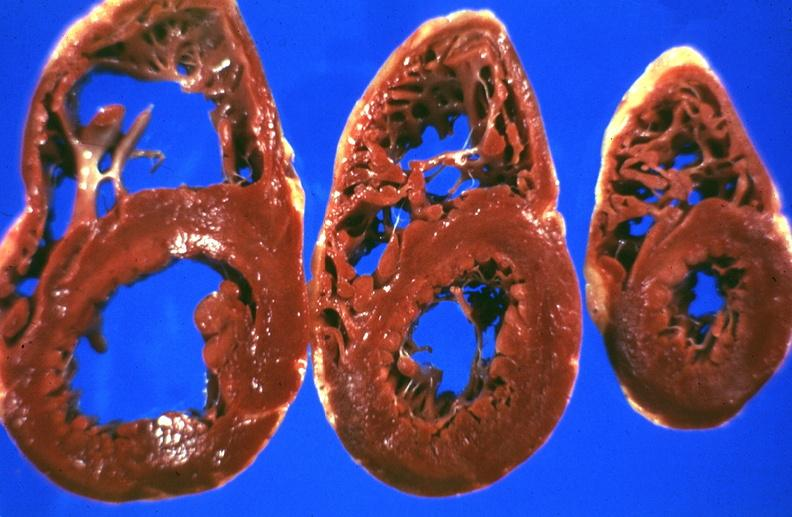s hepatobiliary present?
Answer the question using a single word or phrase. Yes 